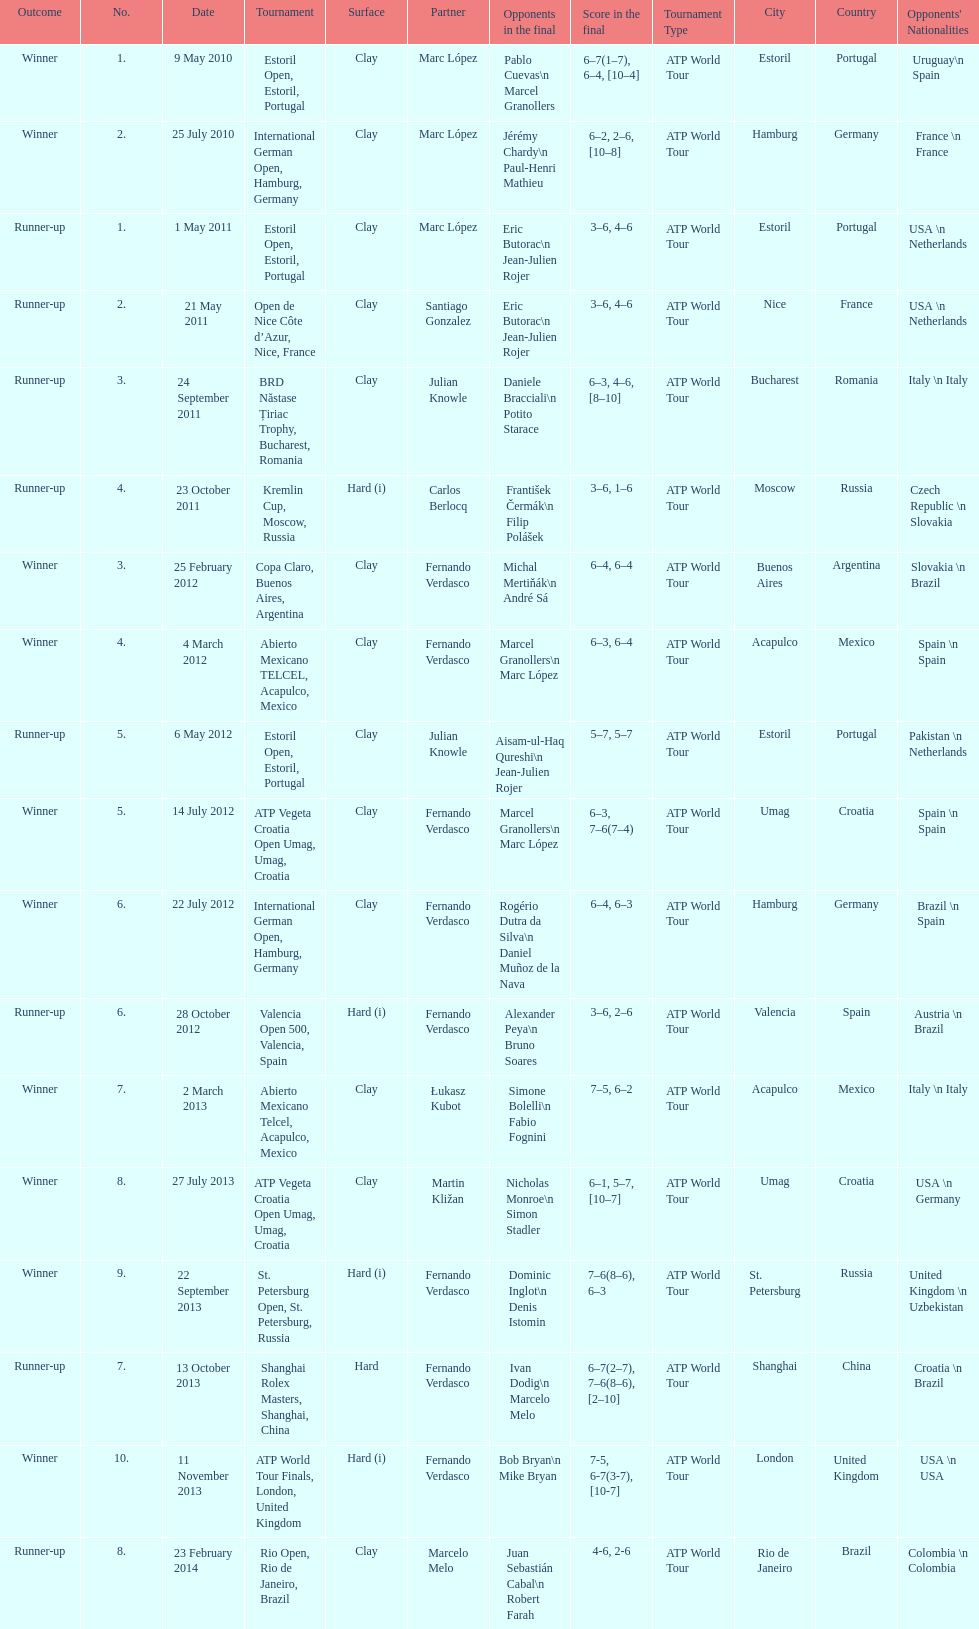What is the total number of runner-ups listed on the chart? 8. 